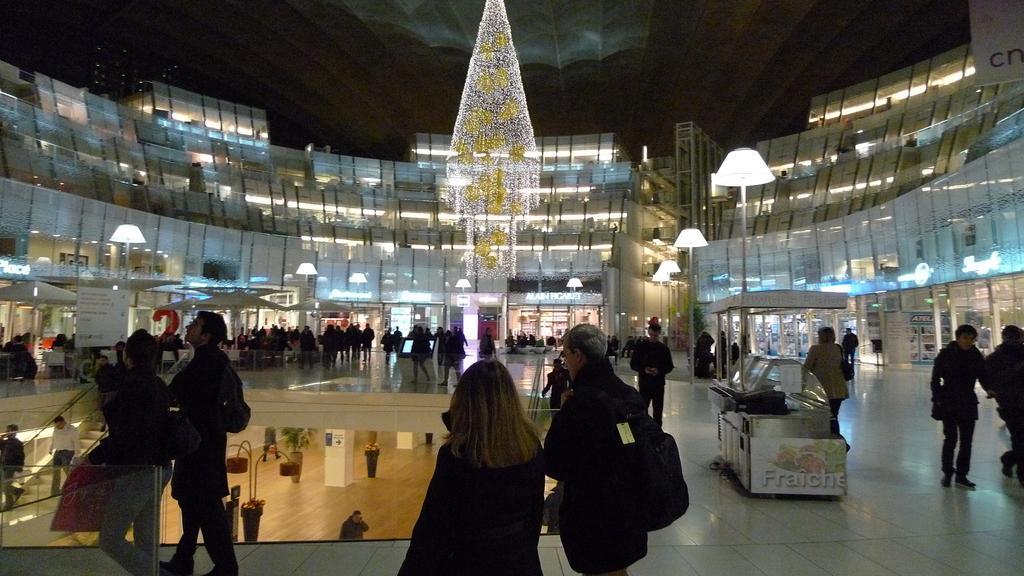In one or two sentences, can you explain what this image depicts? In this image we can see some group of persons walking on the floor there are some stores and in the background of the image we can see glass building, lights and some decoration in the middle of the image, there are stairs on left side of the image. 